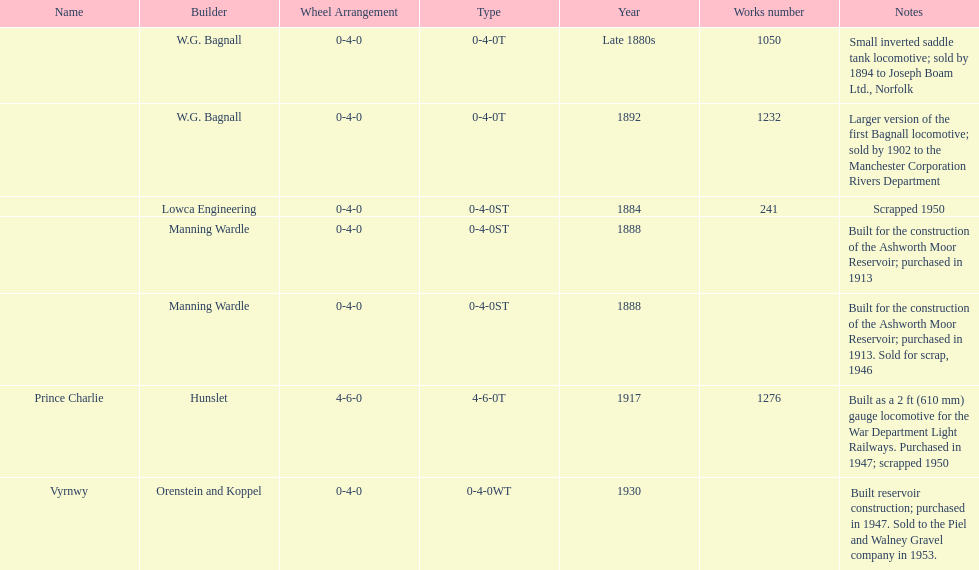How many locomotives were built after 1900? 2. 